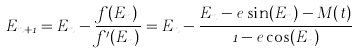Convert formula to latex. <formula><loc_0><loc_0><loc_500><loc_500>E _ { n + 1 } = E _ { n } - { \frac { f ( E _ { n } ) } { f ^ { \prime } ( E _ { n } ) } } = E _ { n } - { \frac { E _ { n } - e \sin ( E _ { n } ) - M ( t ) } { 1 - e \cos ( E _ { n } ) } }</formula> 